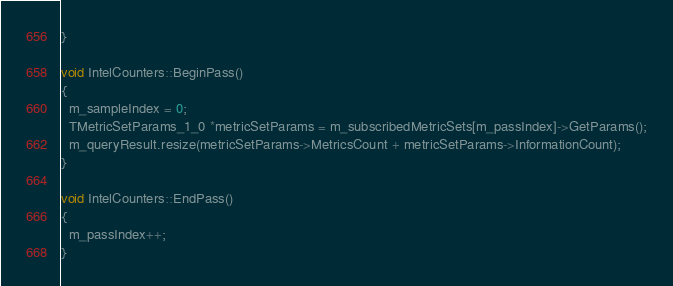<code> <loc_0><loc_0><loc_500><loc_500><_C++_>}

void IntelCounters::BeginPass()
{
  m_sampleIndex = 0;
  TMetricSetParams_1_0 *metricSetParams = m_subscribedMetricSets[m_passIndex]->GetParams();
  m_queryResult.resize(metricSetParams->MetricsCount + metricSetParams->InformationCount);
}

void IntelCounters::EndPass()
{
  m_passIndex++;
}
</code> 